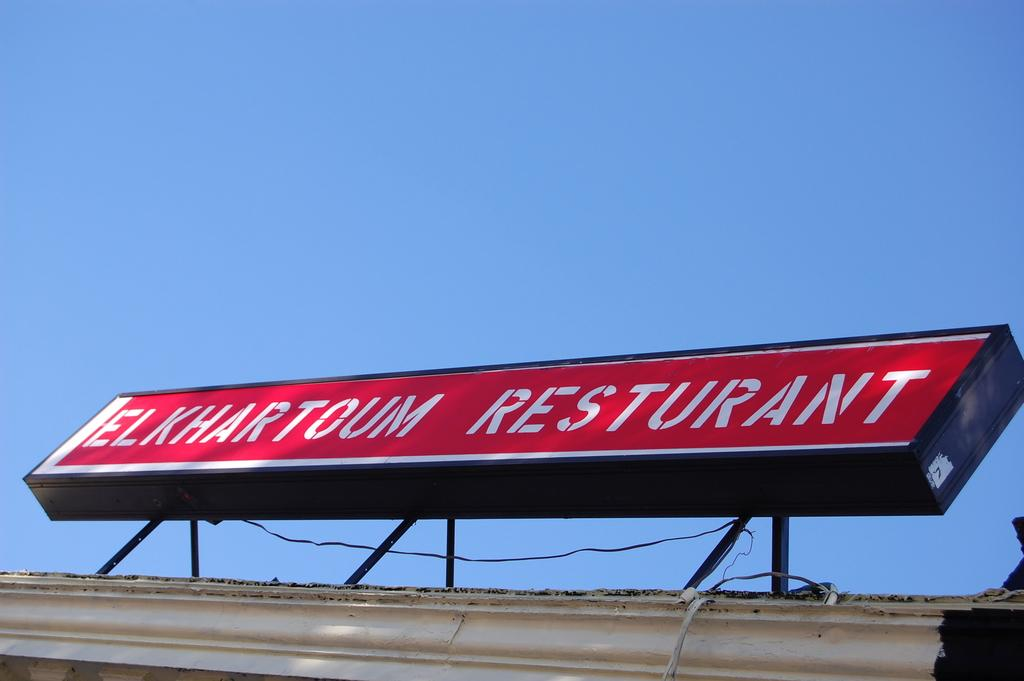<image>
Present a compact description of the photo's key features. A red and white outdoor sign reading Elkhartoum Restaurant. 